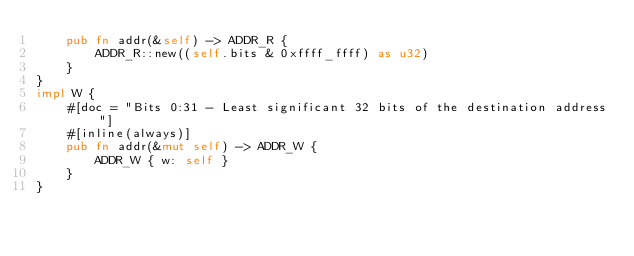<code> <loc_0><loc_0><loc_500><loc_500><_Rust_>    pub fn addr(&self) -> ADDR_R {
        ADDR_R::new((self.bits & 0xffff_ffff) as u32)
    }
}
impl W {
    #[doc = "Bits 0:31 - Least significant 32 bits of the destination address"]
    #[inline(always)]
    pub fn addr(&mut self) -> ADDR_W {
        ADDR_W { w: self }
    }
}
</code> 